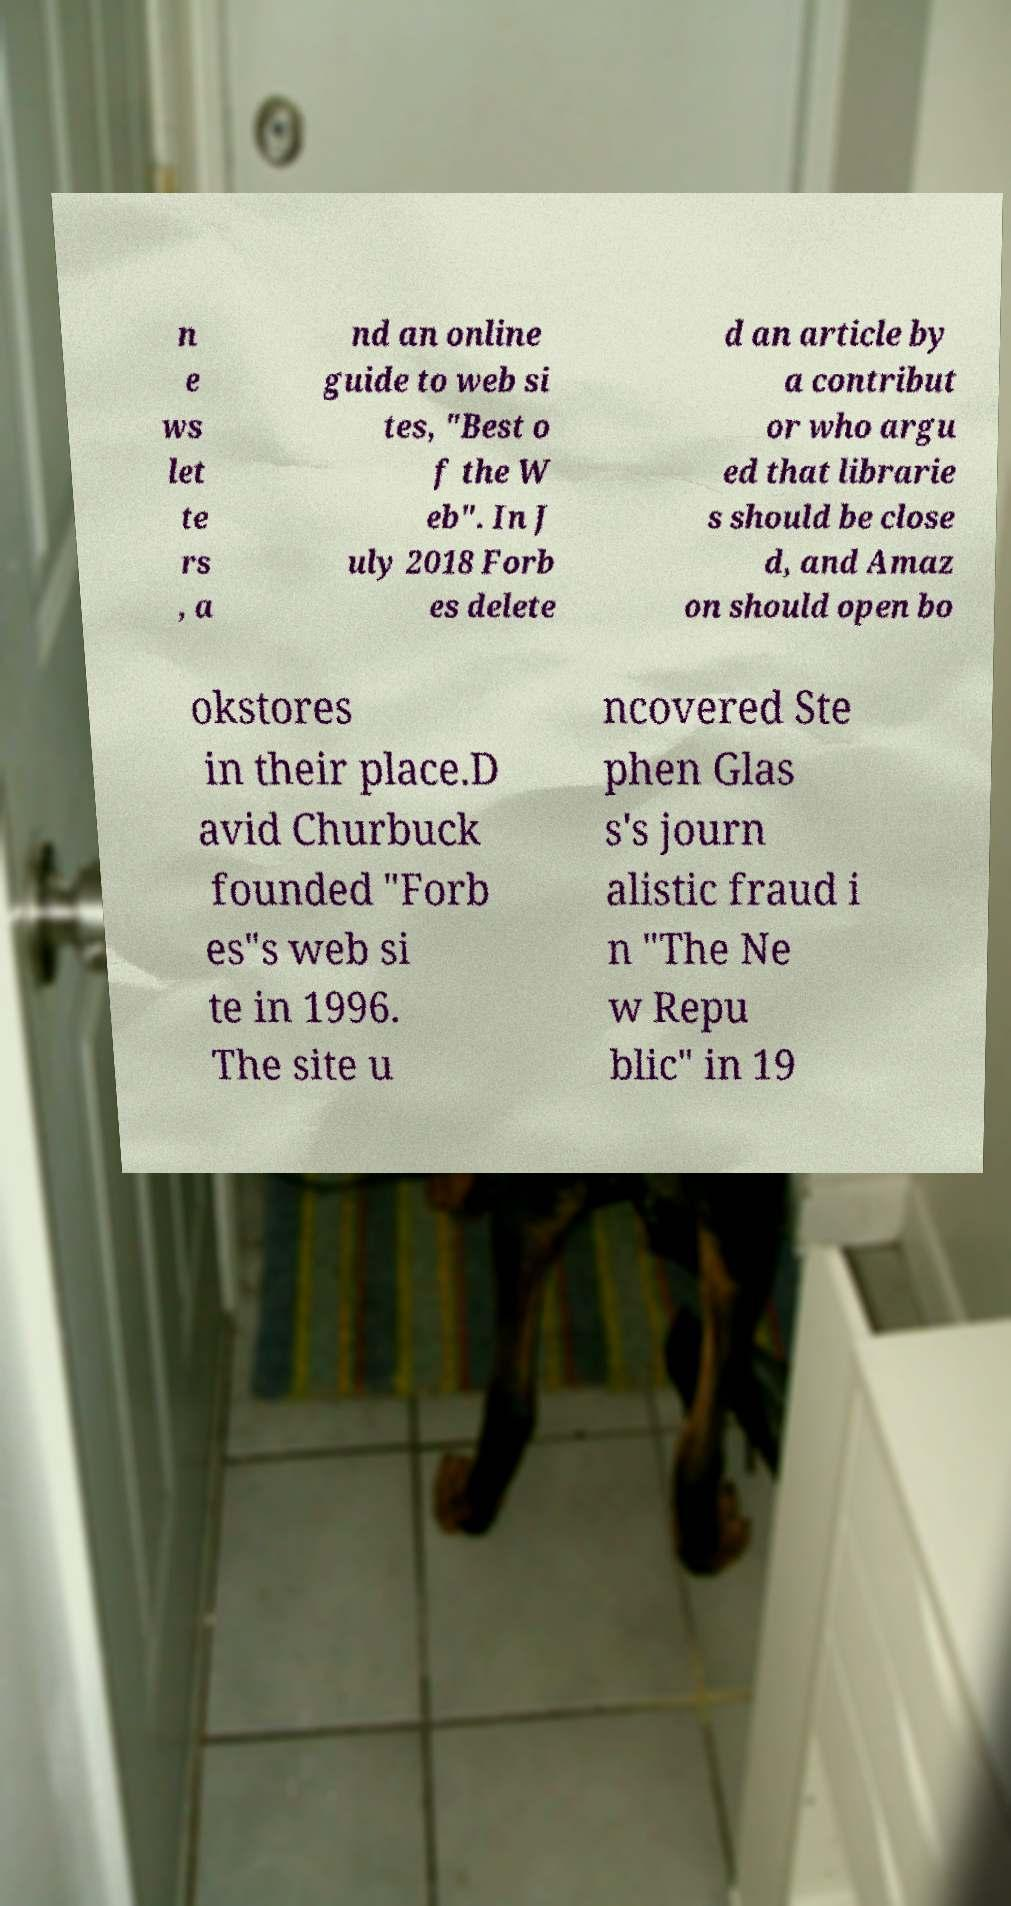Please identify and transcribe the text found in this image. n e ws let te rs , a nd an online guide to web si tes, "Best o f the W eb". In J uly 2018 Forb es delete d an article by a contribut or who argu ed that librarie s should be close d, and Amaz on should open bo okstores in their place.D avid Churbuck founded "Forb es"s web si te in 1996. The site u ncovered Ste phen Glas s's journ alistic fraud i n "The Ne w Repu blic" in 19 